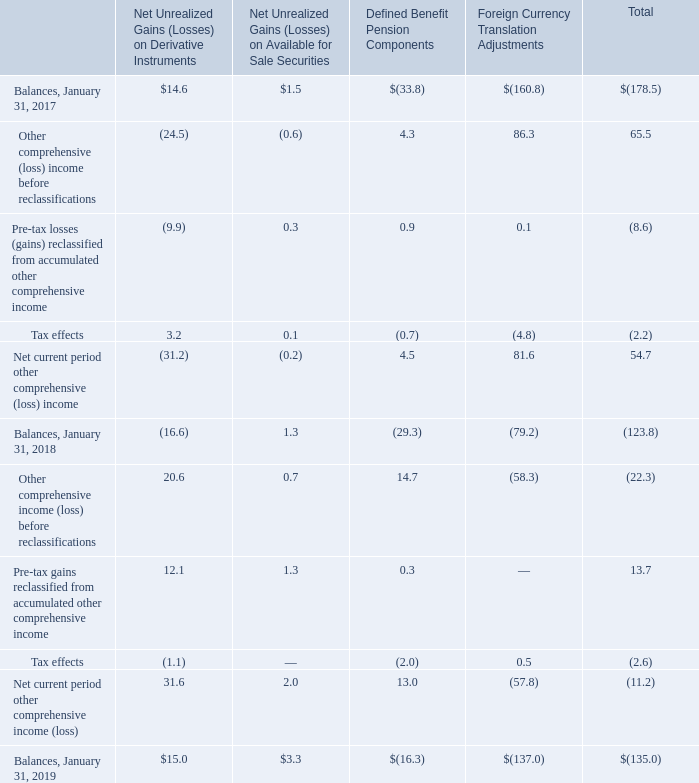12. Accumulated Other Comprehensive Loss
Accumulated other comprehensive loss, net of taxes, consisted of the following:
Reclassifications related to gains and losses on available-for-sale debt securities are included in "Interest and other expense, net". Refer to Note 3, "Financial Instruments" for the amount and location of reclassifications related to derivative instruments. Reclassifications of the defined benefit pension components of net periodic benefit cost are included in "Interest and other expense, net". Refer to Note 15, "Retirement Benefit Plans."
Where are reclassifications related to gains and losses on available-for-sale debt securities included in? Reclassifications related to gains and losses on available-for-sale debt securities are included in "interest and other expense, net". What was the total balance as of January 31, 2019?
Answer scale should be: million. $(135.0). What was the total tax effects as of January 31, 2018?
Answer scale should be: million. (2.6). What was the change in total balances from 2018 to 2019?
Answer scale should be: million. 135.0-123.8
Answer: 11.2. What is the average total balance from 2017 to 2019?
Answer scale should be: million. (178.5+123.8+135.0)/3
Answer: 145.77. What is the average total balance from 2017 to 2019?
Answer scale should be: million. (178.5+123.8+135.0)/3 
Answer: 145.77. 